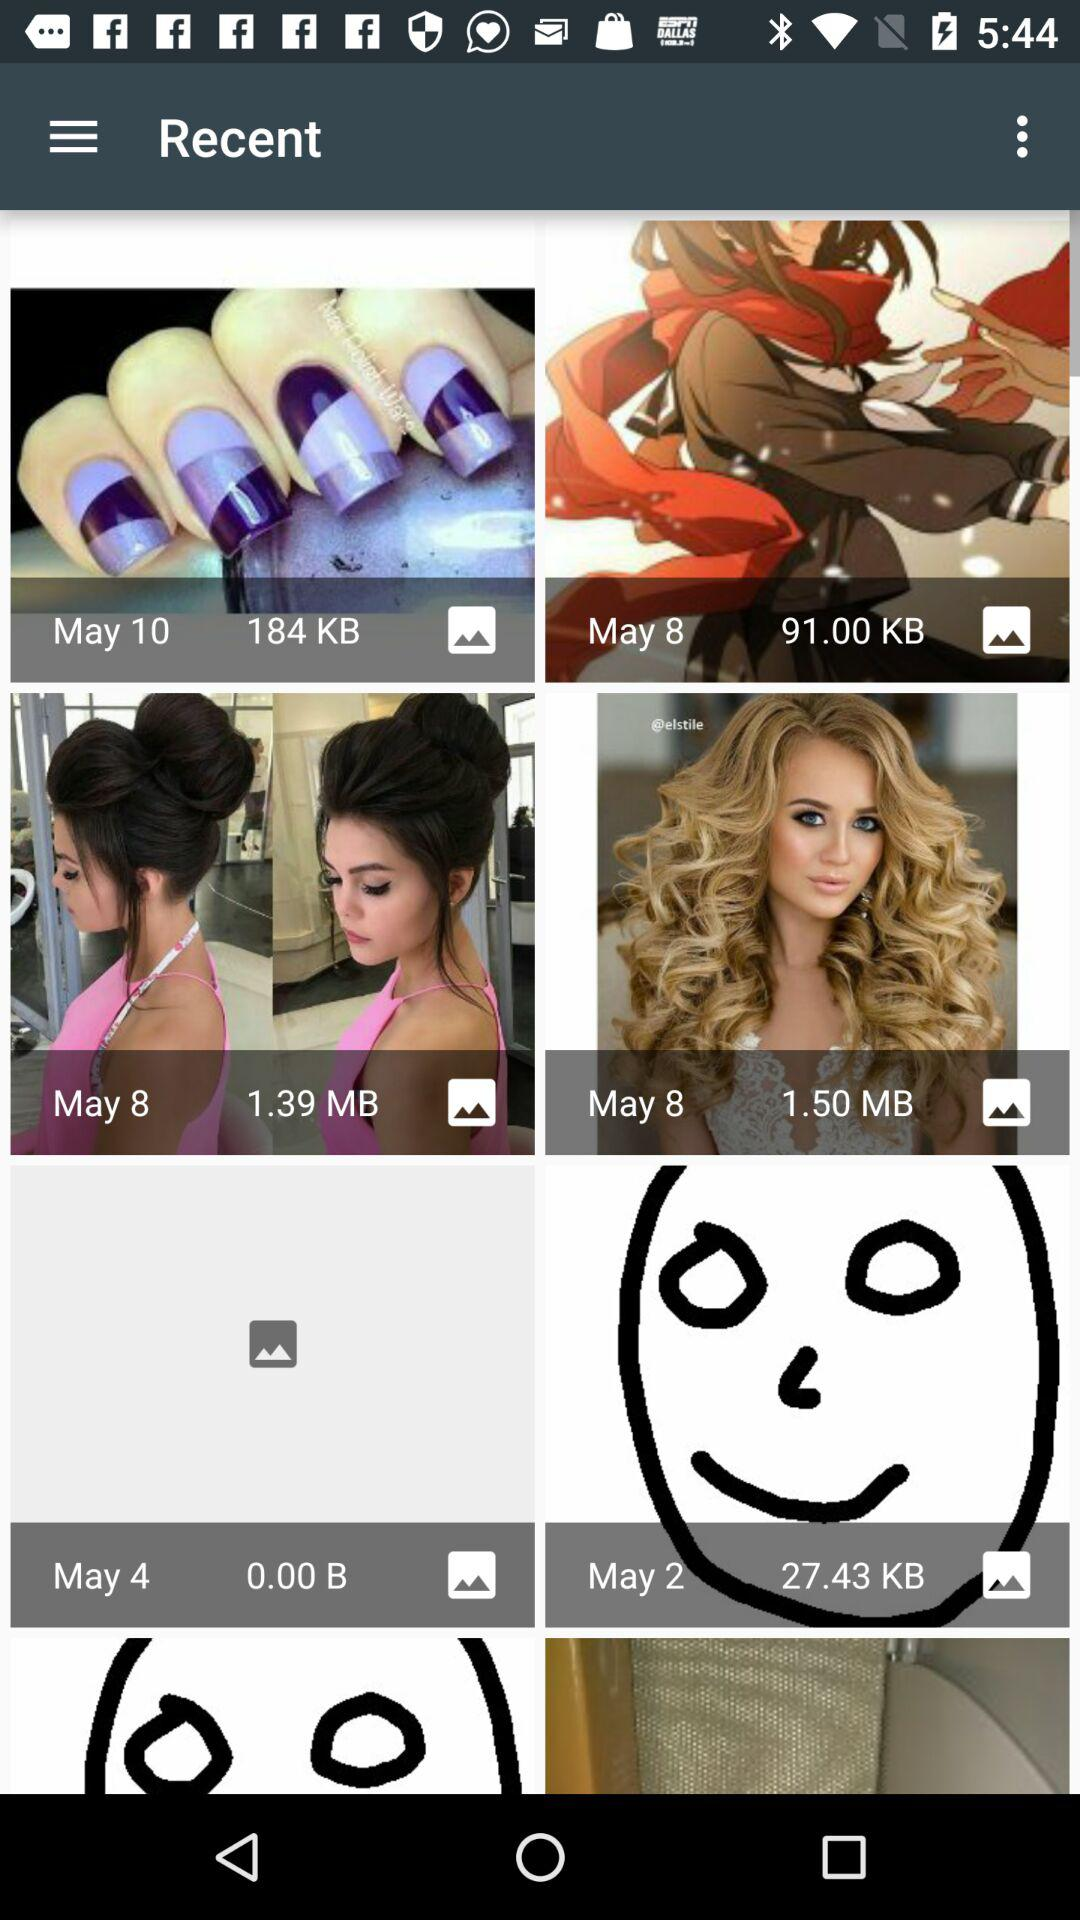What is the size of the photograph, for which the mentioned date is May 2? The size of the photograph is 27.43 KB. 